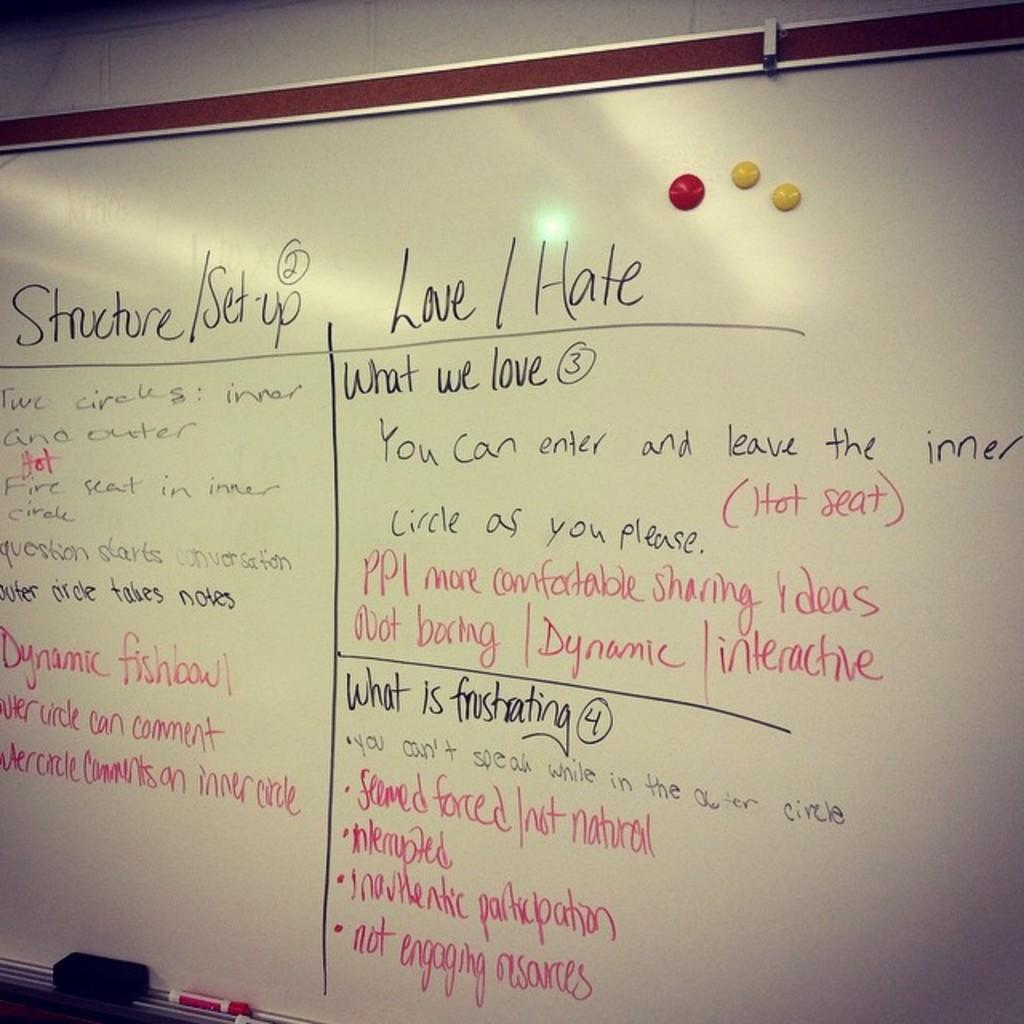Provide a one-sentence caption for the provided image. A classroom discussion of the structure and set up, what they love and hate about the topic, and what's frustrating to them. 